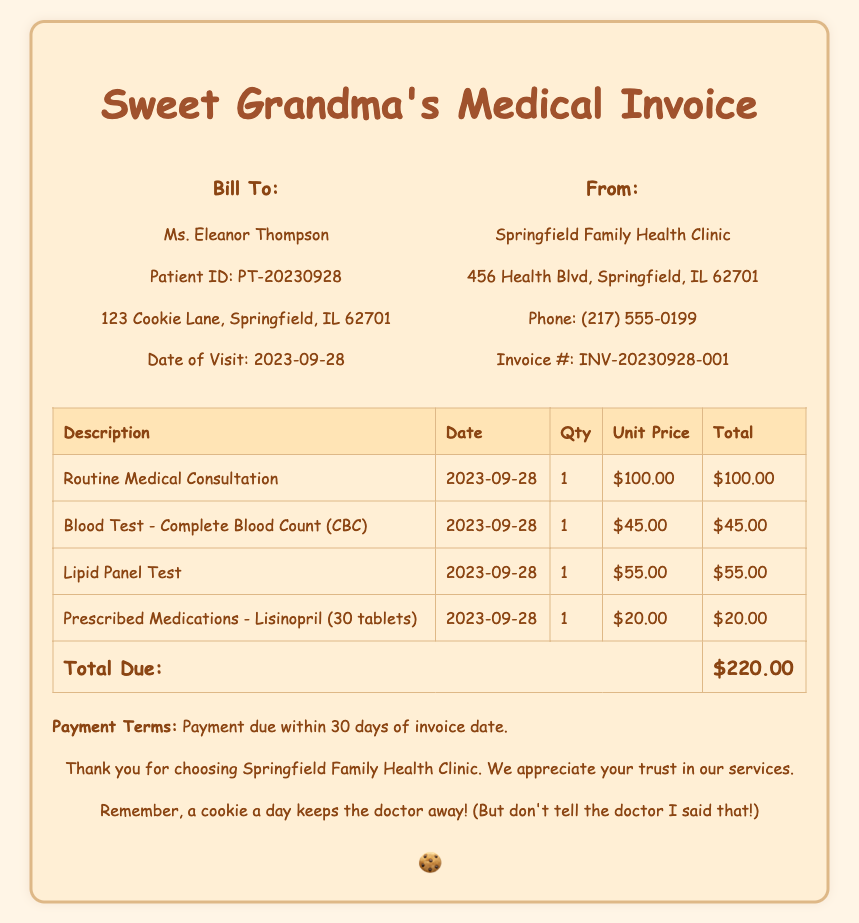What is the patient's name? The patient's name is mentioned in the billing information section of the document.
Answer: Ms. Eleanor Thompson What is the date of the visit? The date of the visit is listed in the billing information section of the invoice.
Answer: 2023-09-28 What is the total due amount? The total due amount is found at the bottom of the itemized charges in the table.
Answer: $220.00 How many prescriptions are included in the invoice? The invoice lists a total of one prescribed medication item.
Answer: 1 What is the unit price of the Lipid Panel Test? The unit price for the Lipid Panel Test is specified in the charges table.
Answer: $55.00 Which clinic issued the invoice? The name of the clinic is presented in the provider information section.
Answer: Springfield Family Health Clinic What is the patient ID? The patient ID is provided in the billing information part of the invoice.
Answer: PT-20230928 What are the payment terms stated in the document? The payment terms are outlined at the bottom of the invoice, specifying the timeframe for payment.
Answer: Payment due within 30 days of invoice date How many tests were performed during the visit? The document lists two specific tests that were performed.
Answer: 2 